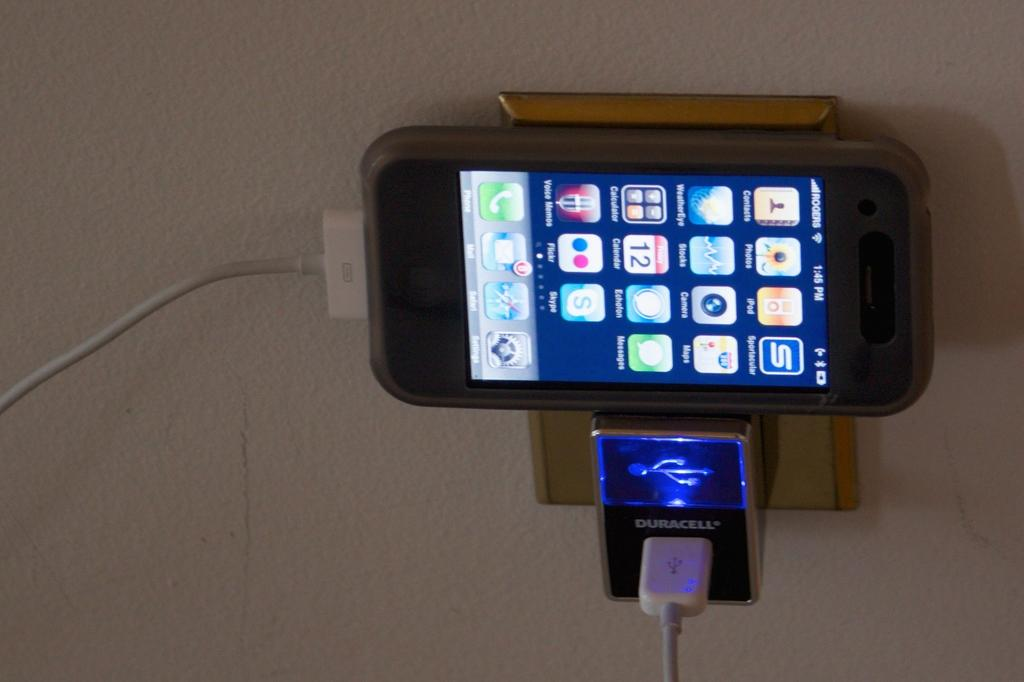<image>
Write a terse but informative summary of the picture. A phone is charging on a Duracell charger. 